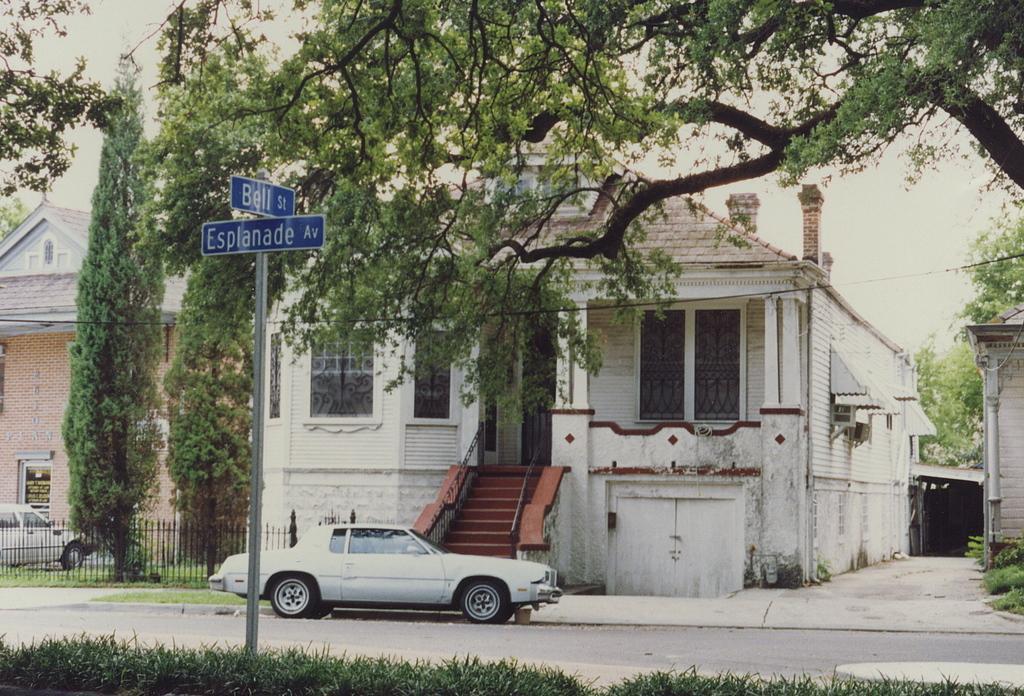How would you summarize this image in a sentence or two? In this image, I can see the houses with the windows. These are the stairs with the staircase holders. I can see two cars, which are parked. These are the trees with branches and leaves. This is a road. I can see two boards, which are attached to a pole. At the bottom of the image, I can see the grass. I think these are the iron grilles. 